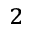<formula> <loc_0><loc_0><loc_500><loc_500>_ { 2 }</formula> 